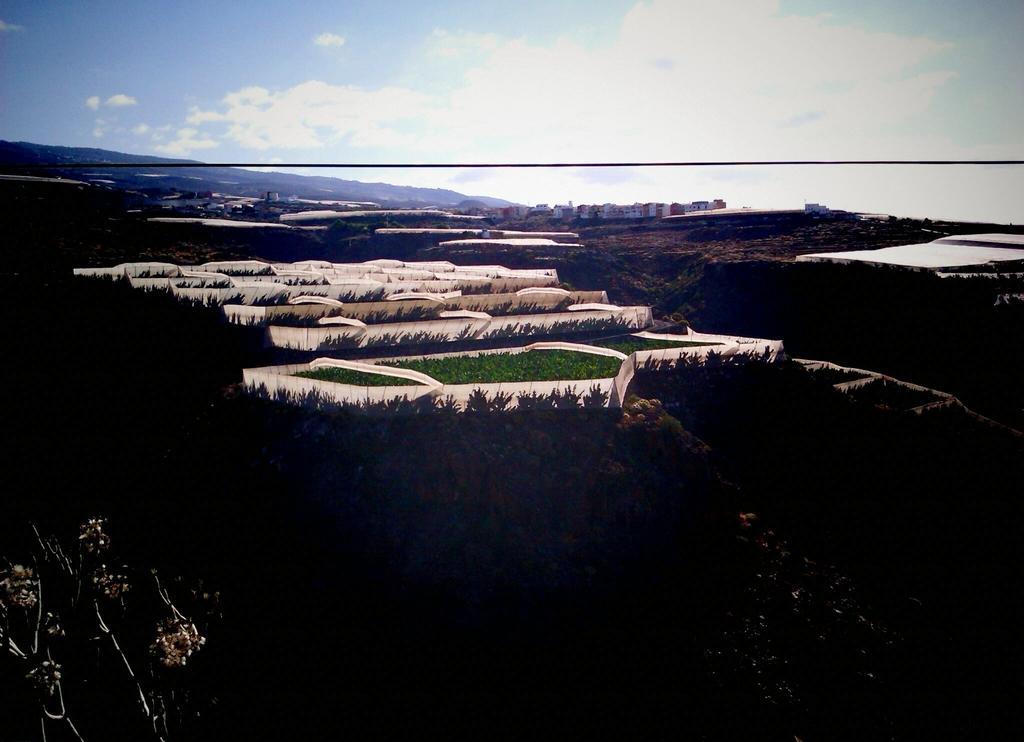How would you summarize this image in a sentence or two? In this image we can see fields and there are trees. In the background there are buildings, hills and sky. 